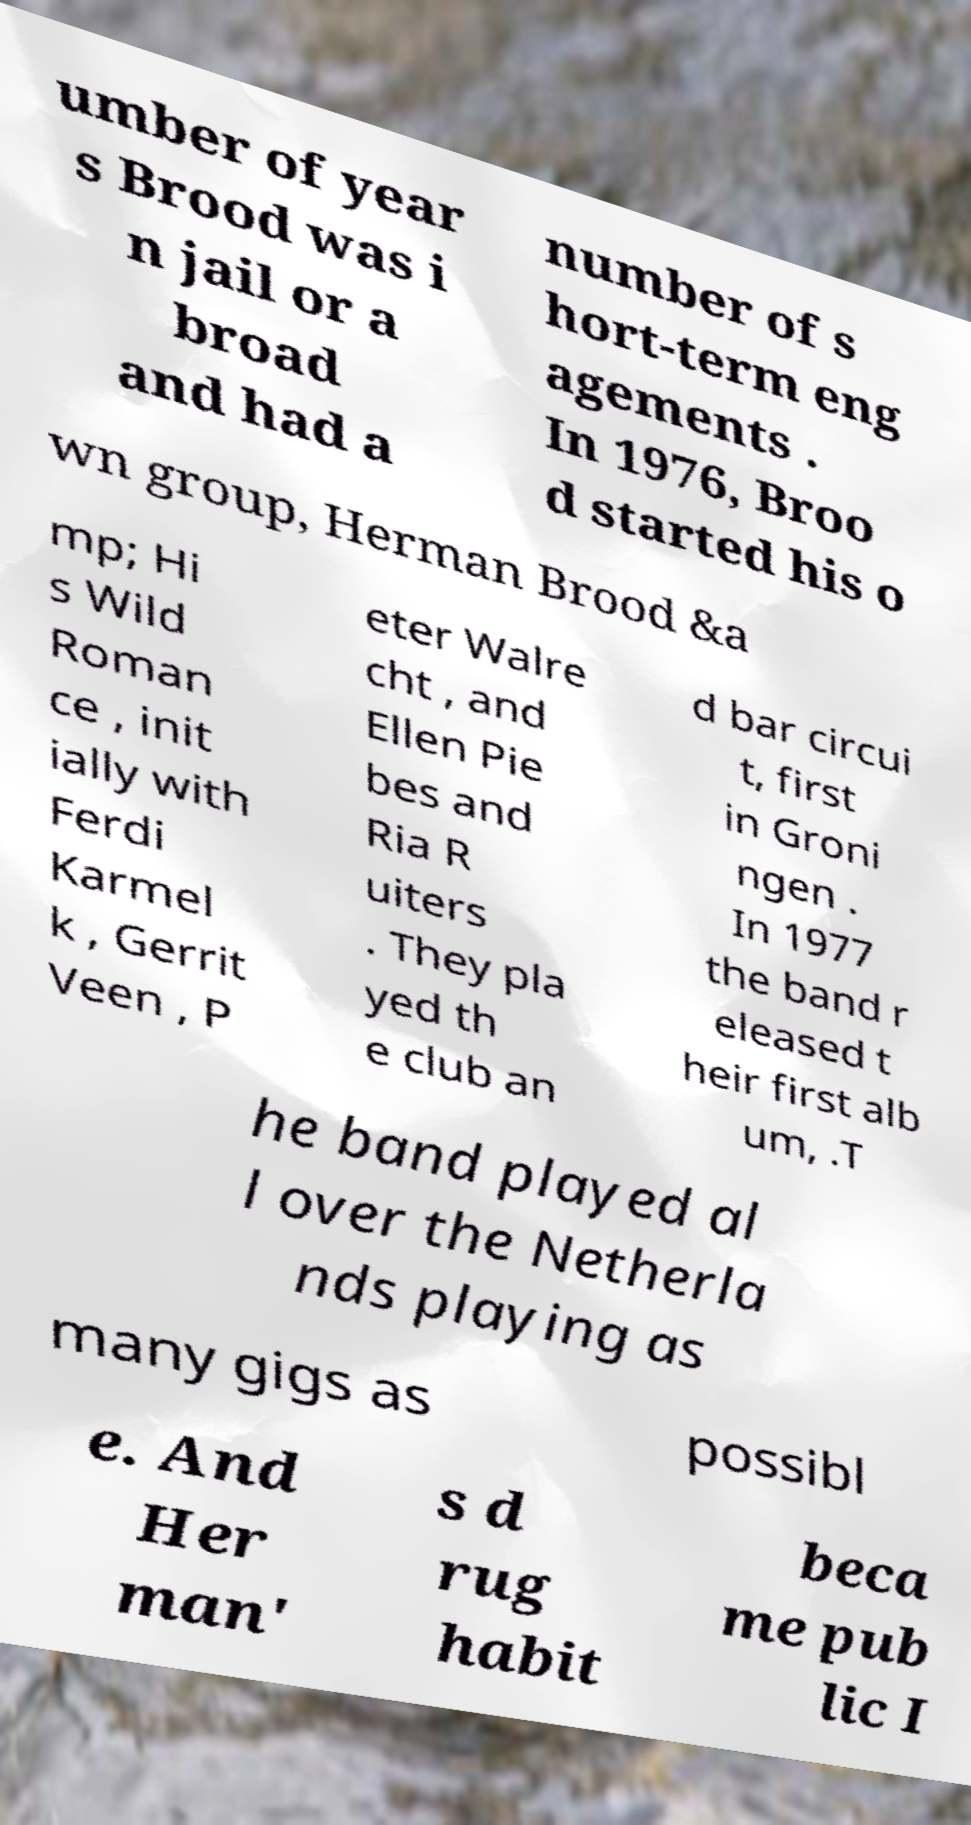Can you accurately transcribe the text from the provided image for me? umber of year s Brood was i n jail or a broad and had a number of s hort-term eng agements . In 1976, Broo d started his o wn group, Herman Brood &a mp; Hi s Wild Roman ce , init ially with Ferdi Karmel k , Gerrit Veen , P eter Walre cht , and Ellen Pie bes and Ria R uiters . They pla yed th e club an d bar circui t, first in Groni ngen . In 1977 the band r eleased t heir first alb um, .T he band played al l over the Netherla nds playing as many gigs as possibl e. And Her man' s d rug habit beca me pub lic I 